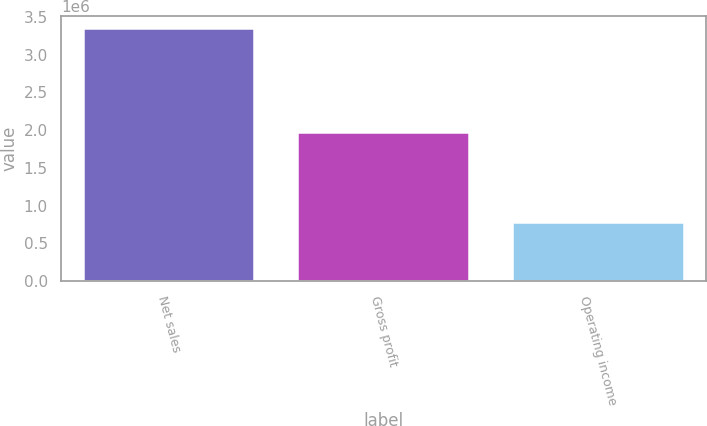Convert chart. <chart><loc_0><loc_0><loc_500><loc_500><bar_chart><fcel>Net sales<fcel>Gross profit<fcel>Operating income<nl><fcel>3.34744e+06<fcel>1.97972e+06<fcel>778343<nl></chart> 